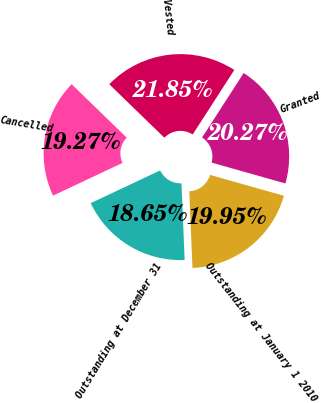Convert chart. <chart><loc_0><loc_0><loc_500><loc_500><pie_chart><fcel>Outstanding at January 1 2010<fcel>Granted<fcel>Vested<fcel>Cancelled<fcel>Outstanding at December 31<nl><fcel>19.95%<fcel>20.27%<fcel>21.85%<fcel>19.27%<fcel>18.65%<nl></chart> 